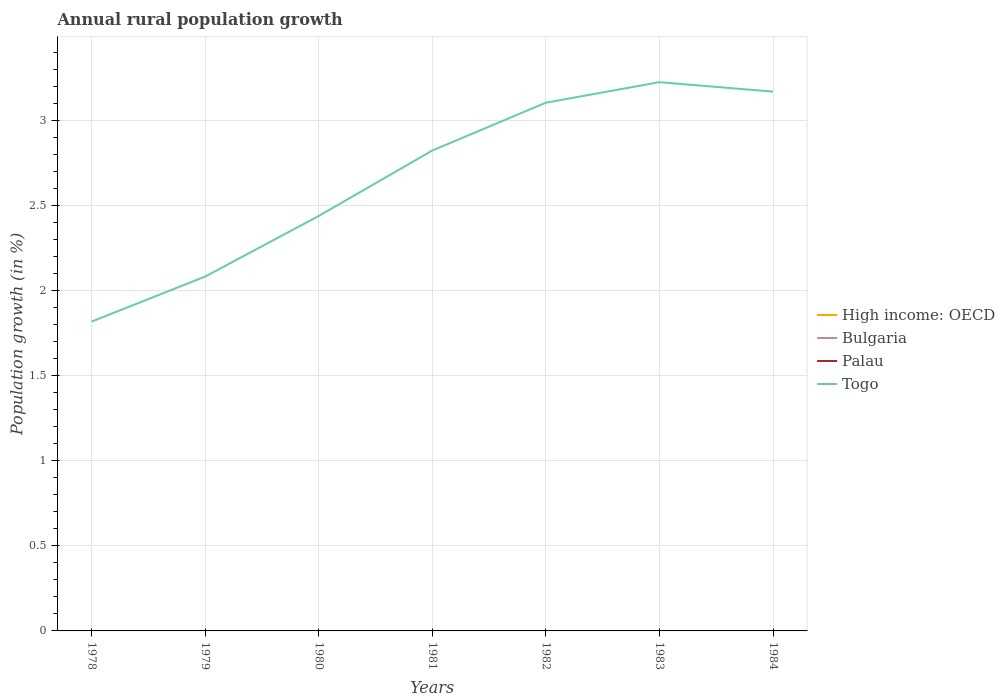How many different coloured lines are there?
Keep it short and to the point. 1. Is the number of lines equal to the number of legend labels?
Provide a short and direct response. No. Across all years, what is the maximum percentage of rural population growth in High income: OECD?
Ensure brevity in your answer.  0. What is the total percentage of rural population growth in Togo in the graph?
Your answer should be very brief. -0.12. How many years are there in the graph?
Give a very brief answer. 7. What is the difference between two consecutive major ticks on the Y-axis?
Make the answer very short. 0.5. Are the values on the major ticks of Y-axis written in scientific E-notation?
Offer a terse response. No. How are the legend labels stacked?
Provide a succinct answer. Vertical. What is the title of the graph?
Your answer should be very brief. Annual rural population growth. Does "Barbados" appear as one of the legend labels in the graph?
Keep it short and to the point. No. What is the label or title of the X-axis?
Ensure brevity in your answer.  Years. What is the label or title of the Y-axis?
Offer a terse response. Population growth (in %). What is the Population growth (in %) in High income: OECD in 1978?
Your response must be concise. 0. What is the Population growth (in %) in Palau in 1978?
Provide a succinct answer. 0. What is the Population growth (in %) in Togo in 1978?
Your response must be concise. 1.82. What is the Population growth (in %) of High income: OECD in 1979?
Keep it short and to the point. 0. What is the Population growth (in %) in Togo in 1979?
Keep it short and to the point. 2.08. What is the Population growth (in %) of High income: OECD in 1980?
Provide a succinct answer. 0. What is the Population growth (in %) of Palau in 1980?
Keep it short and to the point. 0. What is the Population growth (in %) in Togo in 1980?
Your answer should be very brief. 2.44. What is the Population growth (in %) in Togo in 1981?
Your answer should be very brief. 2.82. What is the Population growth (in %) in Togo in 1982?
Offer a very short reply. 3.1. What is the Population growth (in %) of Bulgaria in 1983?
Your response must be concise. 0. What is the Population growth (in %) in Palau in 1983?
Ensure brevity in your answer.  0. What is the Population growth (in %) in Togo in 1983?
Your answer should be very brief. 3.22. What is the Population growth (in %) of Bulgaria in 1984?
Provide a succinct answer. 0. What is the Population growth (in %) in Togo in 1984?
Give a very brief answer. 3.17. Across all years, what is the maximum Population growth (in %) of Togo?
Give a very brief answer. 3.22. Across all years, what is the minimum Population growth (in %) in Togo?
Make the answer very short. 1.82. What is the total Population growth (in %) in Palau in the graph?
Ensure brevity in your answer.  0. What is the total Population growth (in %) in Togo in the graph?
Your response must be concise. 18.66. What is the difference between the Population growth (in %) of Togo in 1978 and that in 1979?
Offer a very short reply. -0.26. What is the difference between the Population growth (in %) in Togo in 1978 and that in 1980?
Offer a terse response. -0.62. What is the difference between the Population growth (in %) of Togo in 1978 and that in 1981?
Offer a terse response. -1.01. What is the difference between the Population growth (in %) of Togo in 1978 and that in 1982?
Your answer should be compact. -1.29. What is the difference between the Population growth (in %) of Togo in 1978 and that in 1983?
Keep it short and to the point. -1.41. What is the difference between the Population growth (in %) in Togo in 1978 and that in 1984?
Provide a short and direct response. -1.35. What is the difference between the Population growth (in %) of Togo in 1979 and that in 1980?
Keep it short and to the point. -0.36. What is the difference between the Population growth (in %) in Togo in 1979 and that in 1981?
Your response must be concise. -0.74. What is the difference between the Population growth (in %) of Togo in 1979 and that in 1982?
Give a very brief answer. -1.02. What is the difference between the Population growth (in %) of Togo in 1979 and that in 1983?
Your answer should be compact. -1.14. What is the difference between the Population growth (in %) in Togo in 1979 and that in 1984?
Provide a short and direct response. -1.09. What is the difference between the Population growth (in %) of Togo in 1980 and that in 1981?
Ensure brevity in your answer.  -0.38. What is the difference between the Population growth (in %) of Togo in 1980 and that in 1982?
Provide a short and direct response. -0.67. What is the difference between the Population growth (in %) in Togo in 1980 and that in 1983?
Your answer should be very brief. -0.79. What is the difference between the Population growth (in %) of Togo in 1980 and that in 1984?
Give a very brief answer. -0.73. What is the difference between the Population growth (in %) of Togo in 1981 and that in 1982?
Your answer should be very brief. -0.28. What is the difference between the Population growth (in %) of Togo in 1981 and that in 1983?
Offer a terse response. -0.4. What is the difference between the Population growth (in %) in Togo in 1981 and that in 1984?
Give a very brief answer. -0.35. What is the difference between the Population growth (in %) of Togo in 1982 and that in 1983?
Offer a terse response. -0.12. What is the difference between the Population growth (in %) in Togo in 1982 and that in 1984?
Your answer should be very brief. -0.06. What is the difference between the Population growth (in %) in Togo in 1983 and that in 1984?
Give a very brief answer. 0.06. What is the average Population growth (in %) of Bulgaria per year?
Provide a short and direct response. 0. What is the average Population growth (in %) of Togo per year?
Make the answer very short. 2.67. What is the ratio of the Population growth (in %) in Togo in 1978 to that in 1979?
Offer a terse response. 0.87. What is the ratio of the Population growth (in %) in Togo in 1978 to that in 1980?
Give a very brief answer. 0.75. What is the ratio of the Population growth (in %) in Togo in 1978 to that in 1981?
Offer a terse response. 0.64. What is the ratio of the Population growth (in %) of Togo in 1978 to that in 1982?
Offer a very short reply. 0.59. What is the ratio of the Population growth (in %) in Togo in 1978 to that in 1983?
Make the answer very short. 0.56. What is the ratio of the Population growth (in %) of Togo in 1978 to that in 1984?
Provide a succinct answer. 0.57. What is the ratio of the Population growth (in %) in Togo in 1979 to that in 1980?
Your answer should be very brief. 0.85. What is the ratio of the Population growth (in %) of Togo in 1979 to that in 1981?
Your answer should be compact. 0.74. What is the ratio of the Population growth (in %) of Togo in 1979 to that in 1982?
Provide a succinct answer. 0.67. What is the ratio of the Population growth (in %) in Togo in 1979 to that in 1983?
Offer a terse response. 0.65. What is the ratio of the Population growth (in %) of Togo in 1979 to that in 1984?
Provide a succinct answer. 0.66. What is the ratio of the Population growth (in %) of Togo in 1980 to that in 1981?
Offer a terse response. 0.86. What is the ratio of the Population growth (in %) of Togo in 1980 to that in 1982?
Your answer should be compact. 0.79. What is the ratio of the Population growth (in %) of Togo in 1980 to that in 1983?
Offer a very short reply. 0.76. What is the ratio of the Population growth (in %) of Togo in 1980 to that in 1984?
Offer a terse response. 0.77. What is the ratio of the Population growth (in %) of Togo in 1981 to that in 1982?
Offer a very short reply. 0.91. What is the ratio of the Population growth (in %) of Togo in 1981 to that in 1983?
Make the answer very short. 0.88. What is the ratio of the Population growth (in %) of Togo in 1981 to that in 1984?
Offer a very short reply. 0.89. What is the ratio of the Population growth (in %) in Togo in 1982 to that in 1983?
Your answer should be very brief. 0.96. What is the ratio of the Population growth (in %) in Togo in 1982 to that in 1984?
Make the answer very short. 0.98. What is the ratio of the Population growth (in %) in Togo in 1983 to that in 1984?
Your response must be concise. 1.02. What is the difference between the highest and the second highest Population growth (in %) of Togo?
Keep it short and to the point. 0.06. What is the difference between the highest and the lowest Population growth (in %) in Togo?
Ensure brevity in your answer.  1.41. 